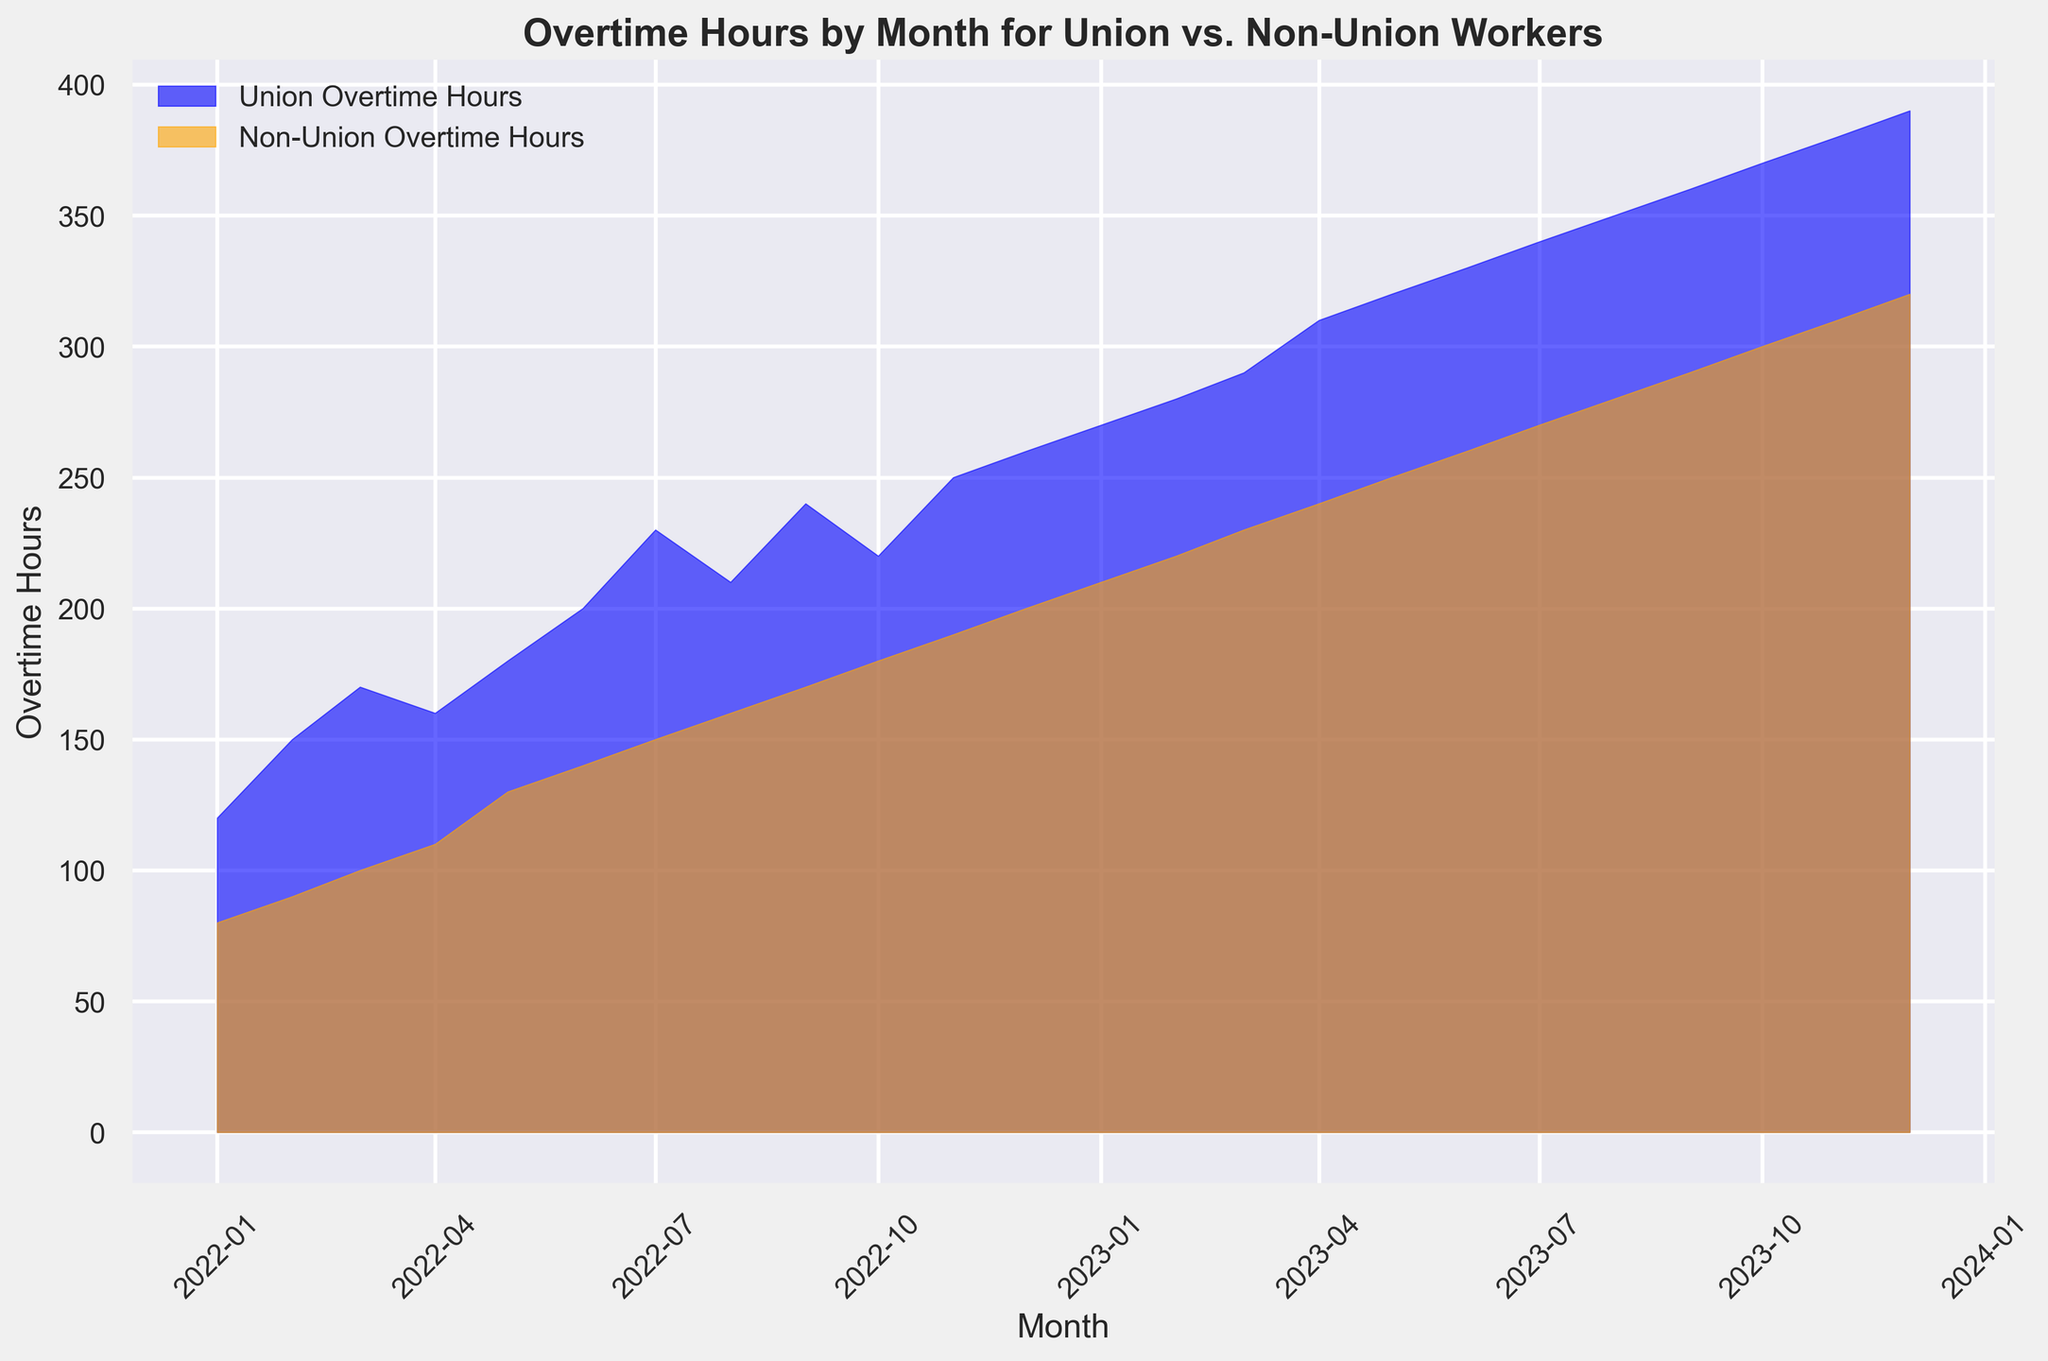When did Union Overtime Hours first exceed 200? Union Overtime Hours surpassed 200 for the first time in June 2022. By looking at the plot, the area representing Union Overtime Hours exceeds the 200-mark in June 2022.
Answer: June 2022 Which group had higher overtime hours in December 2022? By observing the areas for December 2022, the blue area (Union Overtime Hours) is larger than the orange area (Non-Union Overtime Hours), indicating higher overtime hours for union workers.
Answer: Union Workers How has the gap between Union and Non-Union Overtime Hours changed over time? Initially, the gap between Union and Non-Union Overtime Hours was smaller (e.g., January 2022) which then gradually increased over time. By observing the areas, the difference is consistently larger in the later months (e.g., December 2023).
Answer: Increased What is the maximum value of Non-Union Overtime Hours, and when did it occur? The maximum value of Non-Union Overtime Hours occurs in December 2023, indicated by the peak of the orange area, which is 320 hours.
Answer: 320 hours, December 2023 When did Union Overtime Hours reach 270 for the first time? Union Overtime Hours reached 270 in January 2023. By noting the progression, the blue area first meets the 270-mark at January 2023.
Answer: January 2023 What visual changes signify increasing trends in both Union and Non-Union Overtime Hours from the beginning to the end of the observed period? The overall height and area covered by both blue (Union) and orange (Non-Union) regions increase continuously from January 2022 to December 2023, showing an upward trend.
Answer: Increasing area and height In which month is the difference in overtime hours between Union and Non-Union workers most significant? By observing the plot, November 2023 indicates a large gap between the blue and orange areas, making the difference most significant.
Answer: November 2023 What is the total Union Overtime Hours for the first half of 2022? The total is the sum of Union Overtime Hours from January to June 2022: (120 + 150 + 170 + 160 + 180 + 200) = 980 hours.
Answer: 980 hours Is there any month where Union and Non-Union Overtime Hours are equal? By examining the overlap between the blue and orange areas, no month shows equal values for Union and Non-Union Overtime Hours.
Answer: No What is the average monthly Non-Union Overtime Hours for 2023? To find the average, sum the monthly Non-Union Overtime Hours for 2023 and divide by 12: (210 + 220 + 230 + 240 + 250 + 260 + 270 + 280 + 290 + 300 + 310 + 320) / 12 = 271.67.
Answer: 271.67 